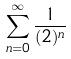Convert formula to latex. <formula><loc_0><loc_0><loc_500><loc_500>\sum _ { n = 0 } ^ { \infty } \frac { 1 } { ( 2 ) ^ { n } }</formula> 